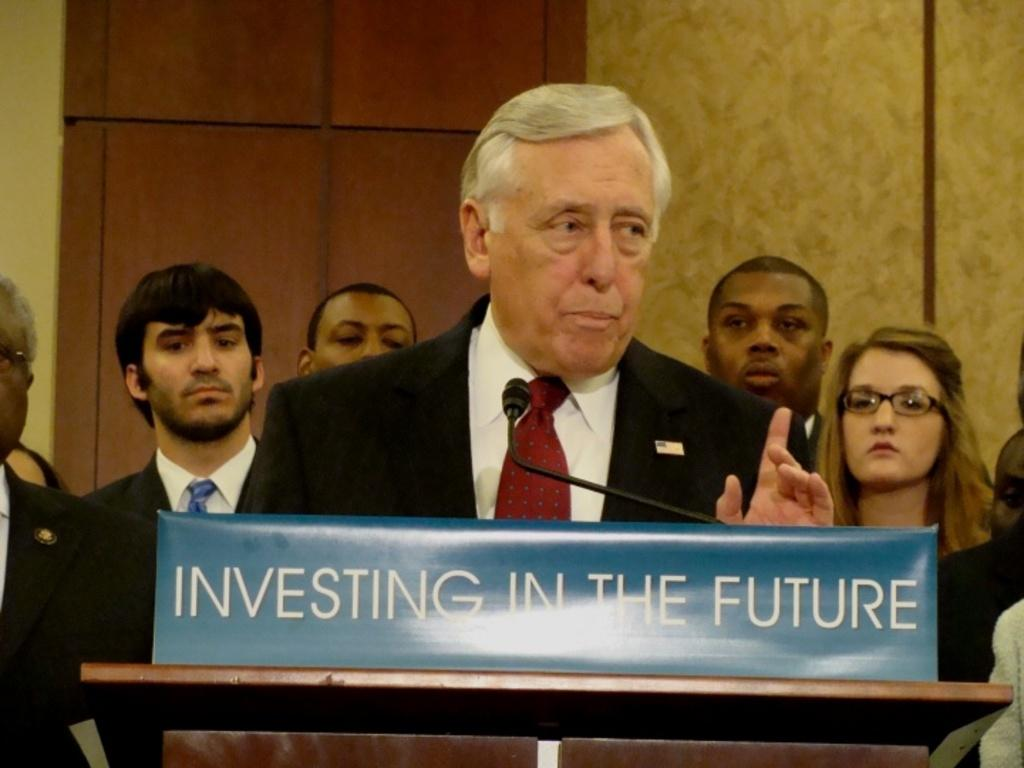What is the man in the image doing? The man is talking on a microphone. What object is present in front of the man? There is a podium in the image. Who else is in the image besides the man with the microphone? There are people present in the image. What can be seen behind the man and the people? There is a wall in the background of the image. What type of pot is the farmer using to skate in the image? There is no pot, farmer, or skate present in the image. 